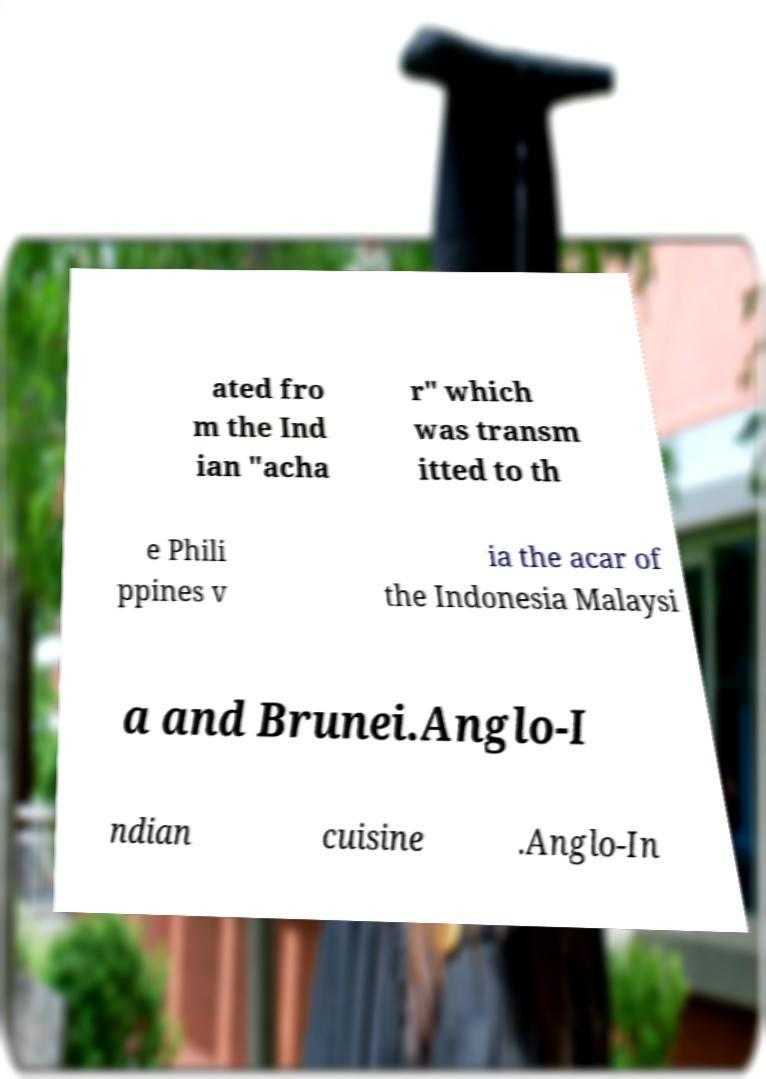Please read and relay the text visible in this image. What does it say? ated fro m the Ind ian "acha r" which was transm itted to th e Phili ppines v ia the acar of the Indonesia Malaysi a and Brunei.Anglo-I ndian cuisine .Anglo-In 